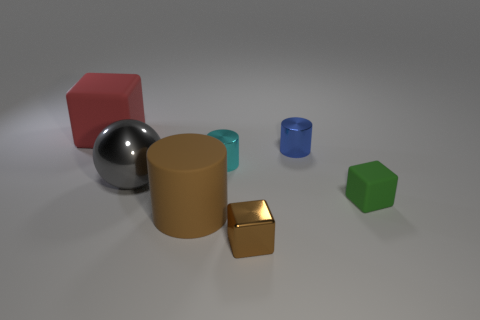Add 2 cyan cylinders. How many objects exist? 9 Subtract all cylinders. How many objects are left? 4 Subtract all shiny spheres. Subtract all rubber cylinders. How many objects are left? 5 Add 7 large brown matte things. How many large brown matte things are left? 8 Add 7 large blue metal things. How many large blue metal things exist? 7 Subtract 1 blue cylinders. How many objects are left? 6 